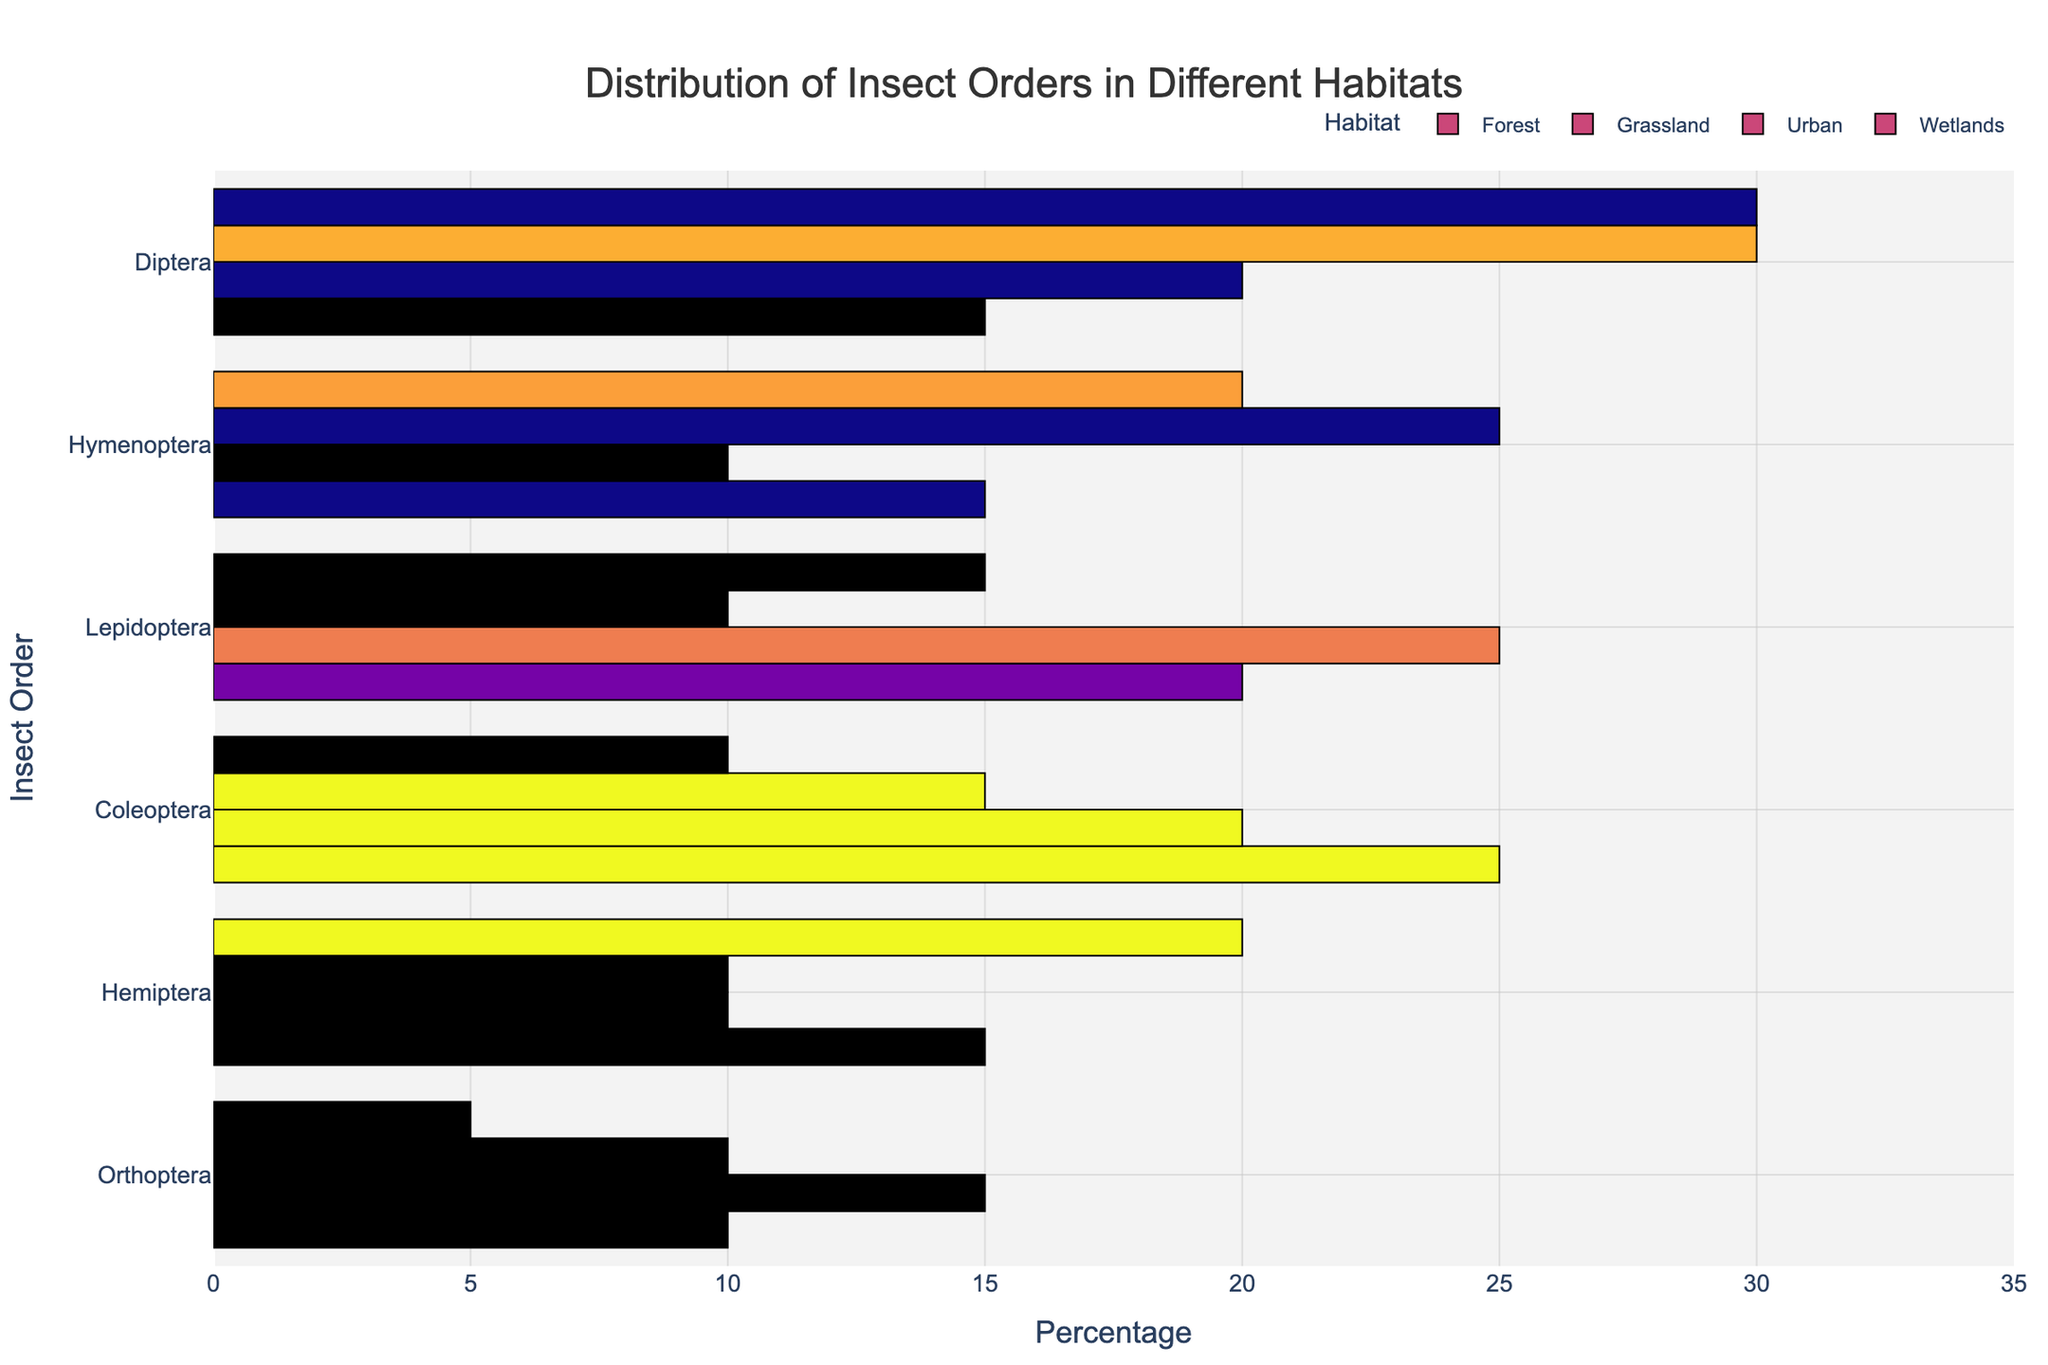What insect order is most abundant in the urban habitat? Look at the bar representing the urban habitat, and identify which order has the highest percentage bar length. Hymenoptera has the longest bar at 30%.
Answer: Hymenoptera Which habitat has the highest percentage of Lepidoptera? Compare the bars corresponding to Lepidoptera across all habitats. Grassland shows the highest bar at 25%.
Answer: Grassland How much higher is the percentage of Diptera in wetlands compared to grasslands? Calculate the difference between Diptera percentages in wetlands and grasslands: 30% (wetlands) - 20% (grasslands) = 10%.
Answer: 10% Which insect order is least represented in the forest habitat compared to others? In the forest habitat, find the order with the shortest percentage bar. Orthoptera has the lowest at 10%.
Answer: Orthoptera What is the average percentage of Coleoptera across all habitats? Sum the percentages of Coleoptera in all habitats and divide by the number of habitats: (25% + 20% + 15% + 10%) / 4 = 70% / 4 = 17.5%.
Answer: 17.5% In which habitat does Hemiptera have an equal percentage to Orthoptera? Look at the habitat where Hemiptera and Orthoptera have bars of equal length. They are equal at 10% in the Urban habitat.
Answer: Urban Compare the relative abundance of Hymenoptera in forest and urban habitats. Compare the length of the Hymenoptera bars in forest and urban habitats. In the forest, it is 15%; in urban, it is 25%. Hymenoptera is more abundant in the urban habitat.
Answer: Urban What is the combined percentage of Diptera and Hemiptera in the wetlands habitat? Add the percentages of Diptera and Hemiptera in wetlands: 30% + 20% = 50%.
Answer: 50% Which two insect orders have the same percentage distribution in the grassland habitat? Identify orders in the grassland habitat that have bars of equal length. Hymenoptera and Hemiptera both have 10%.
Answer: Hymenoptera and Hemiptera 